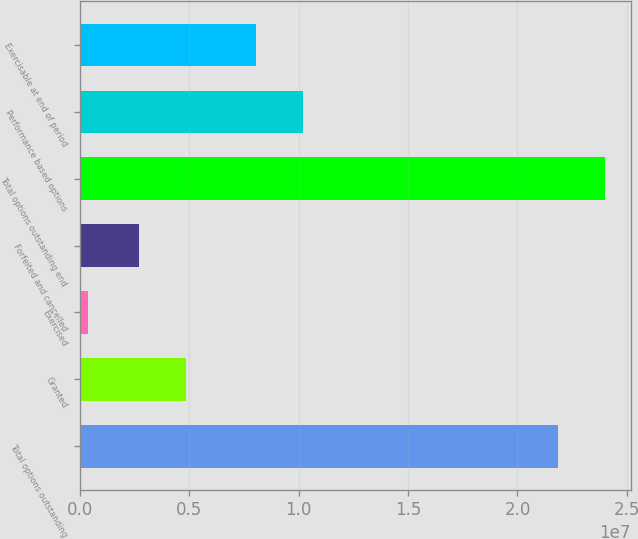<chart> <loc_0><loc_0><loc_500><loc_500><bar_chart><fcel>Total options outstanding<fcel>Granted<fcel>Exercised<fcel>Forfeited and cancelled<fcel>Total options outstanding end<fcel>Performance based options<fcel>Exercisable at end of period<nl><fcel>2.18357e+07<fcel>4.84469e+06<fcel>356793<fcel>2.6942e+06<fcel>2.39862e+07<fcel>1.02126e+07<fcel>8.06209e+06<nl></chart> 